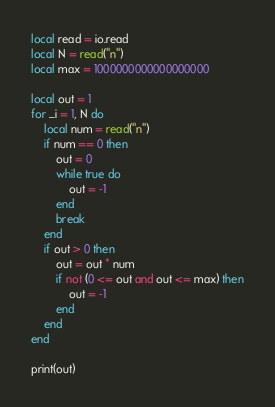<code> <loc_0><loc_0><loc_500><loc_500><_Lua_>local read = io.read
local N = read("n")
local max = 1000000000000000000

local out = 1
for _i = 1, N do
	local num = read("n")
	if num == 0 then
		out = 0
		while true do
			out = -1
		end
		break
	end
	if out > 0 then
		out = out * num
		if not (0 <= out and out <= max) then
			out = -1
		end
	end
end

print(out)
</code> 